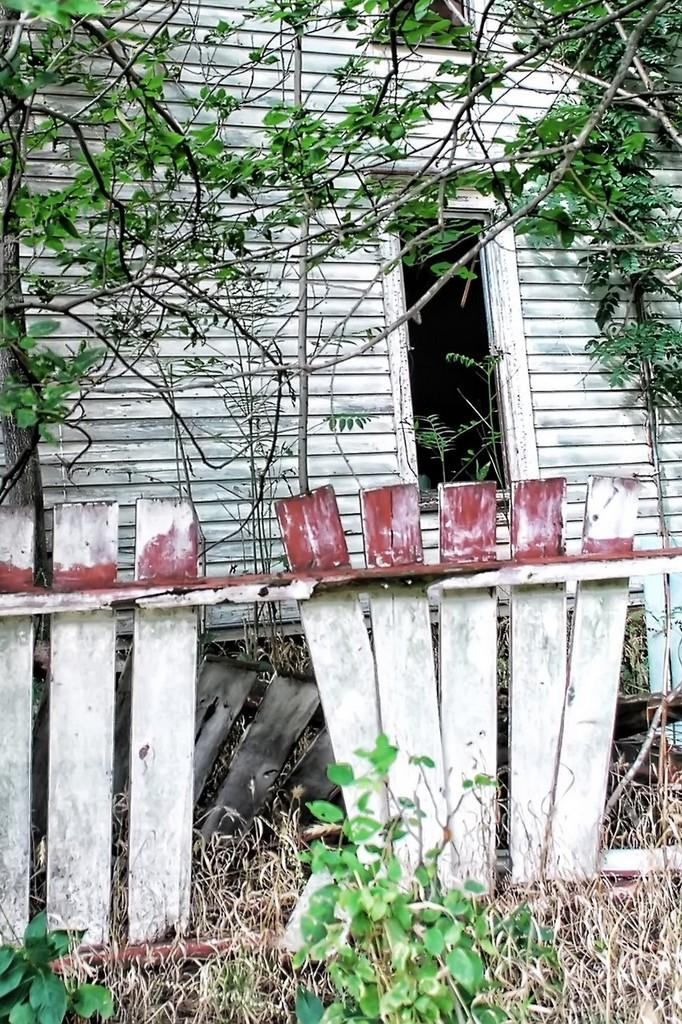What type of fence is visible in the image? There is a wooden fence in the image. What structure is located behind the wooden fence? There appears to be a house behind the wooden fence. What type of vegetation is in front of the house? Branches of trees are visible in front of the house. What else can be seen in front of the house? There are other objects present in front of the house. What type of stone is being cut by the scissors in the image? There are no scissors or stone present in the image. How many turkeys can be seen in the image? There are no turkeys present in the image. 